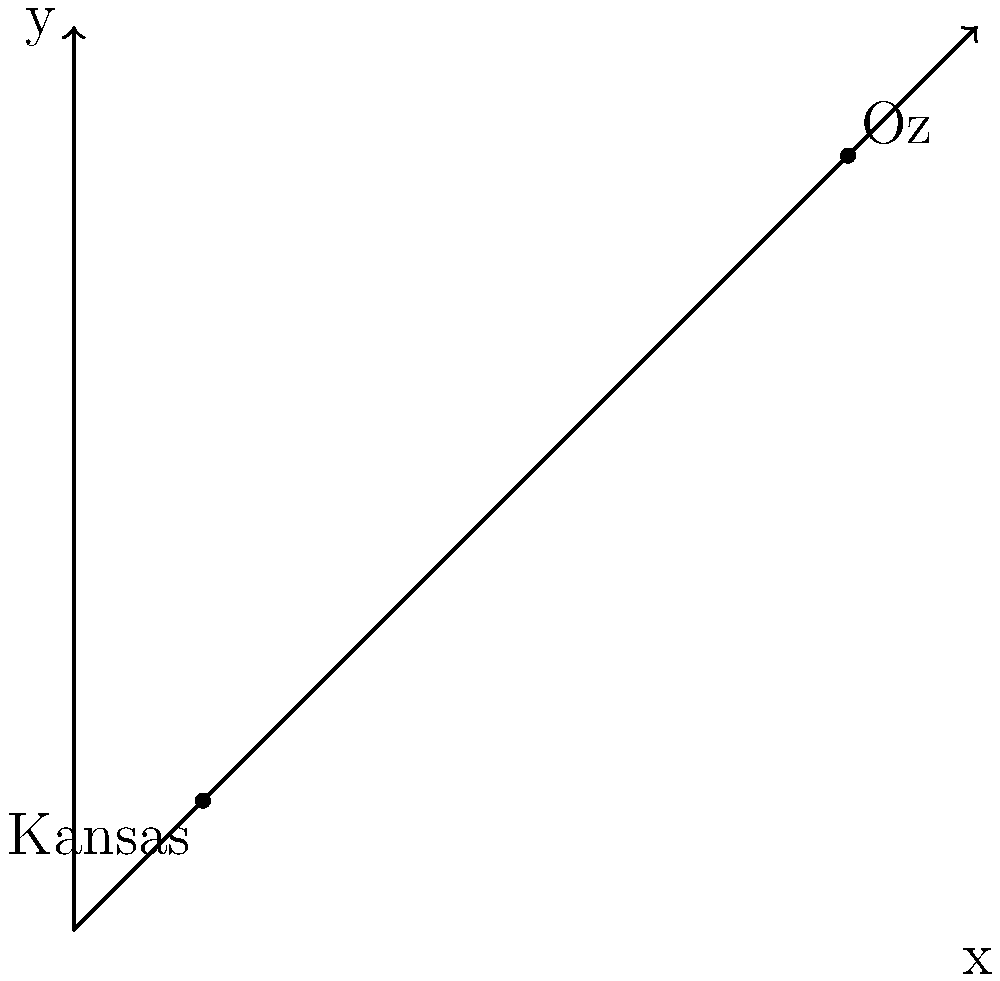In the Emerald City's magical map, Oz is located at coordinates (3, 4) and Kansas at (-2, -1). What is the distance between Oz and Kansas on this enchanted Cartesian plane? Let's follow the yellow brick road to solve this problem:

1) We can use the distance formula between two points on a Cartesian plane:
   $$d = \sqrt{(x_2-x_1)^2 + (y_2-y_1)^2}$$

2) Let's identify our points:
   Oz: $(x_1, y_1) = (3, 4)$
   Kansas: $(x_2, y_2) = (-2, -1)$

3) Now, let's substitute these into our formula:
   $$d = \sqrt{(-2-3)^2 + (-1-4)^2}$$

4) Simplify inside the parentheses:
   $$d = \sqrt{(-5)^2 + (-5)^2}$$

5) Calculate the squares:
   $$d = \sqrt{25 + 25}$$

6) Add inside the square root:
   $$d = \sqrt{50}$$

7) Simplify the square root:
   $$d = 5\sqrt{2}$$

Thus, the distance between Oz and Kansas on this magical map is $5\sqrt{2}$ units.
Answer: $5\sqrt{2}$ units 